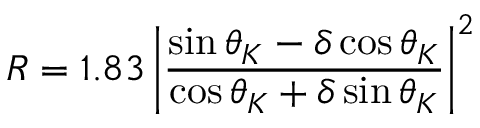<formula> <loc_0><loc_0><loc_500><loc_500>R = 1 . 8 3 \left | { \frac { \sin \theta _ { K } - \delta \cos \theta _ { K } } { \cos \theta _ { K } + \delta \sin \theta _ { K } } } \right | ^ { 2 }</formula> 